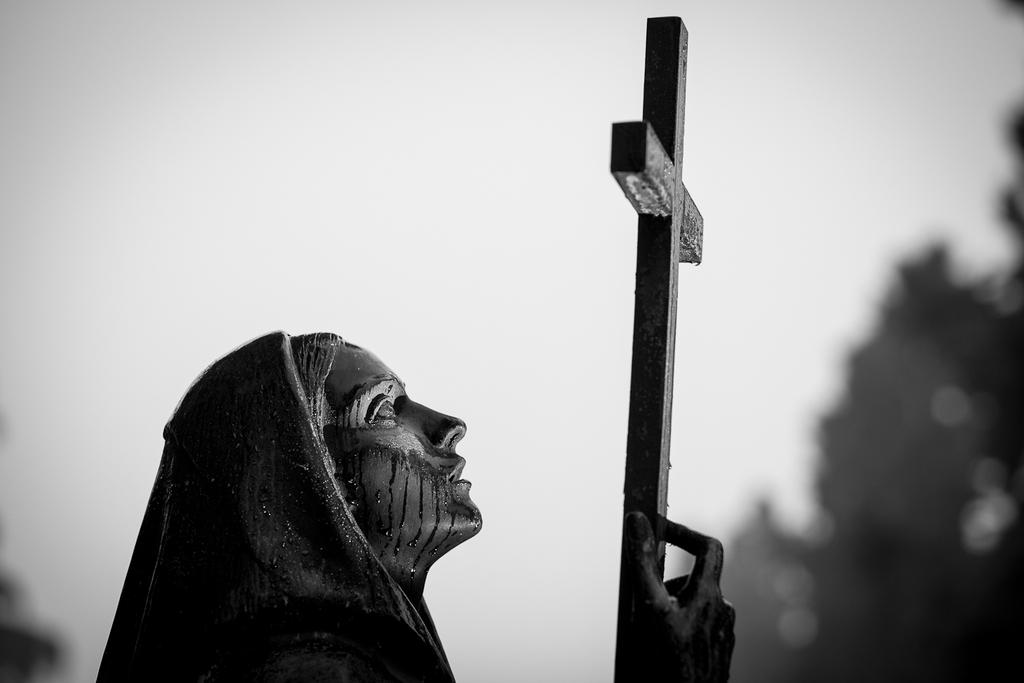What is the color scheme of the image? The image is black and white. What is the main subject in the image? There is a statue in the image. What can be seen in the background of the image? There are trees and the sky visible in the background of the image. How many pets are visible in the image? There are no pets present in the image. What is the best way to achieve success in the image? The image does not depict any actions or achievements, so it is not possible to determine the best way to achieve success from the image. 